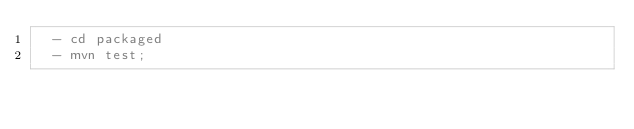<code> <loc_0><loc_0><loc_500><loc_500><_YAML_>  - cd packaged 
  - mvn test;
</code> 